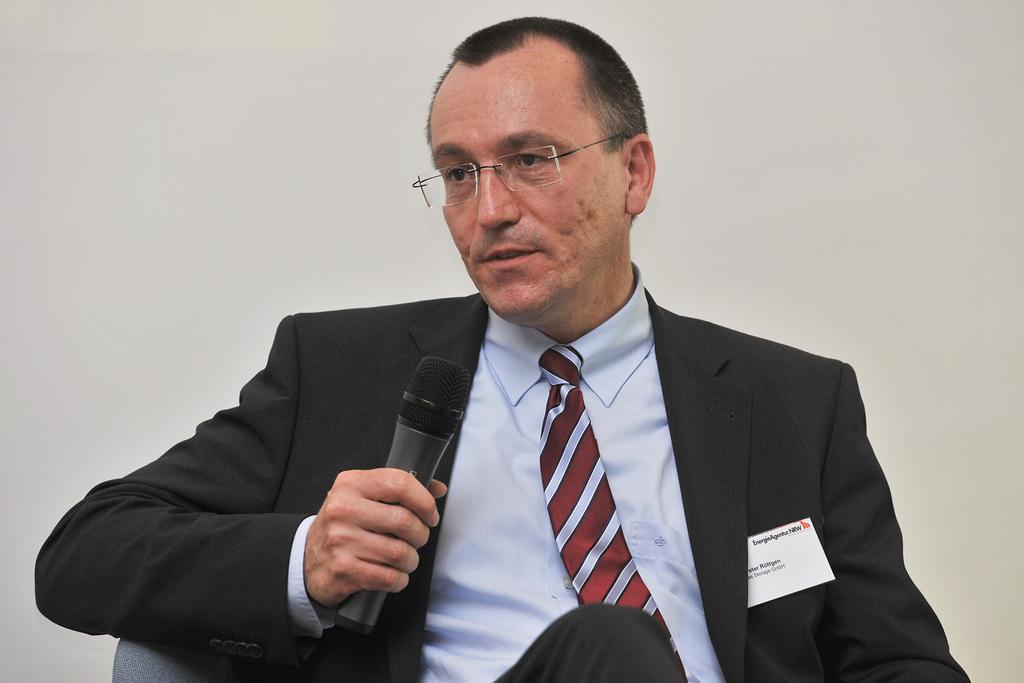In one or two sentences, can you explain what this image depicts? A man is sitting in the chair he wear a tie, shirt and talking in the microphone. 